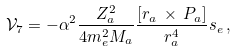Convert formula to latex. <formula><loc_0><loc_0><loc_500><loc_500>\mathcal { V } _ { 7 } = - \alpha ^ { 2 } \frac { Z _ { a } ^ { 2 } } { 4 m _ { e } ^ { 2 } M _ { a } } \frac { [ r _ { a } \, \times \, P _ { a } ] } { r _ { a } ^ { 4 } } s _ { e } \, ,</formula> 